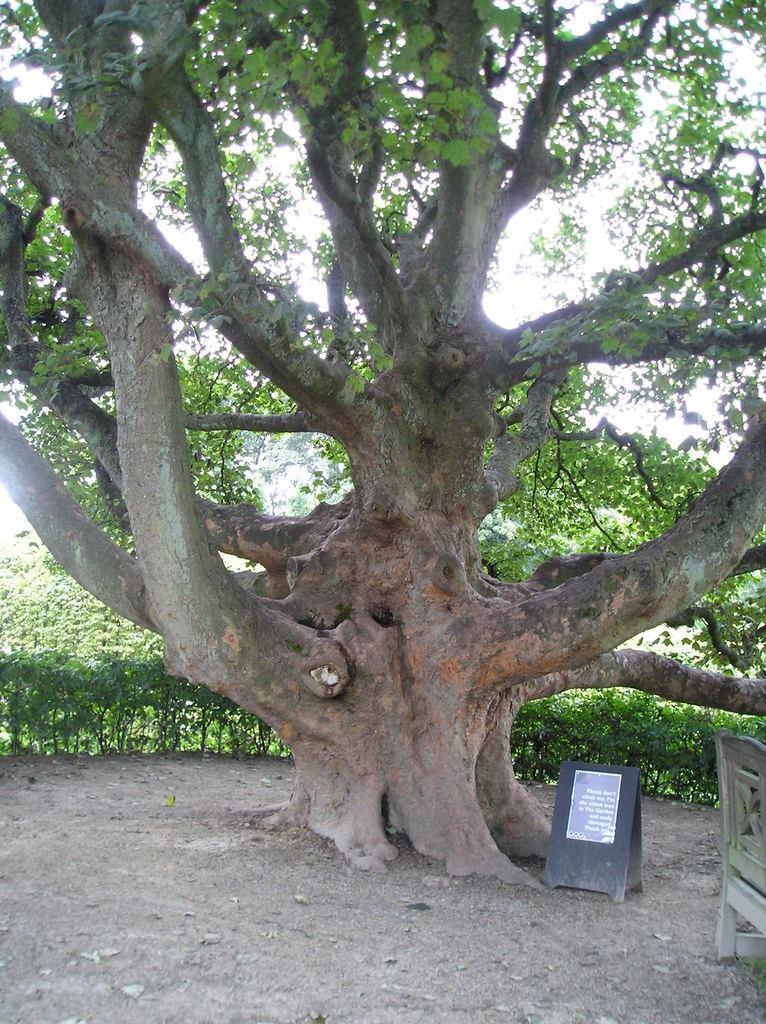In one or two sentences, can you explain what this image depicts? In this image we can see a bench, tree and plants, also we can see a board, on the board, we can see a poster with some text, in the background, we can see the sky. 